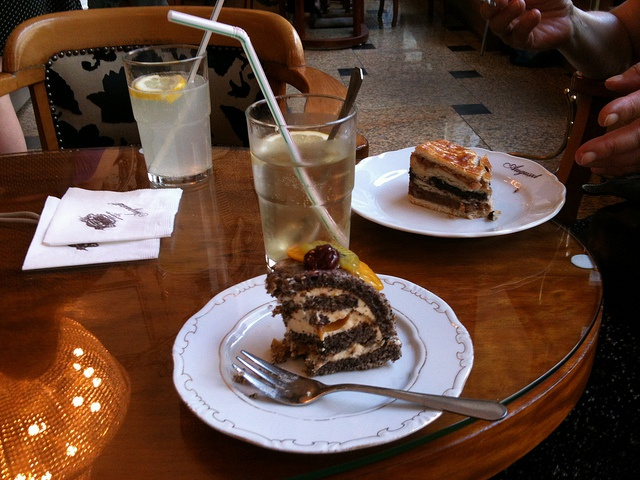Describe the objects in this image and their specific colors. I can see dining table in black, maroon, and lavender tones, chair in black, maroon, and brown tones, cup in black, maroon, and gray tones, cake in black, maroon, and gray tones, and people in black, maroon, gray, and brown tones in this image. 